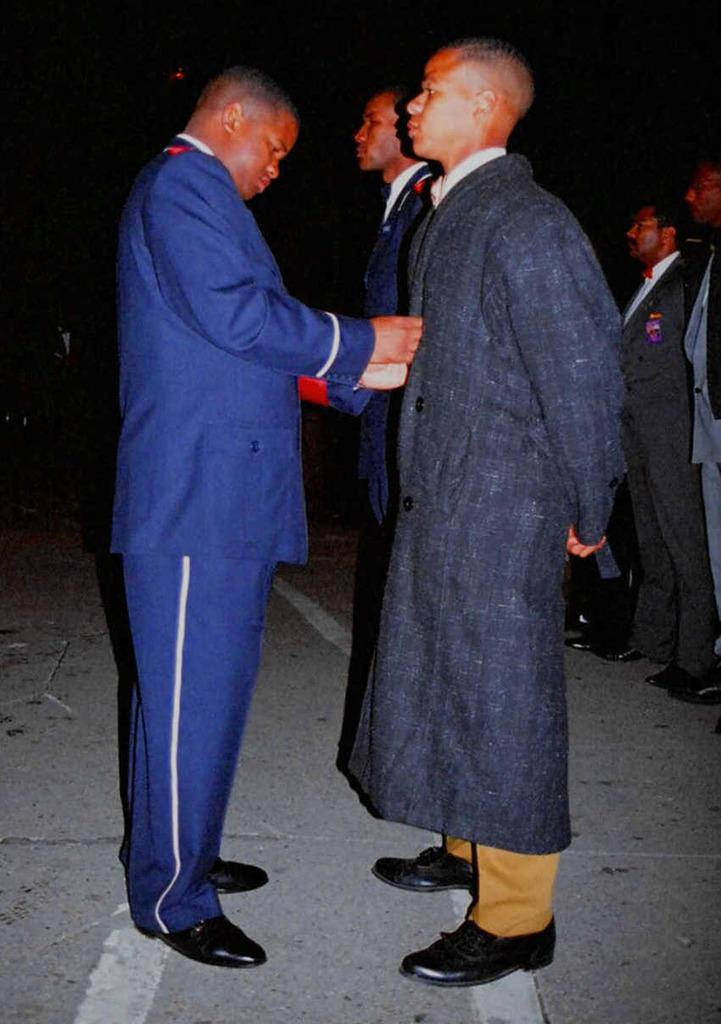What are the people in the image doing? The men in the image are standing. What are the men wearing? The men are wearing suits. What can be observed about the background of the image? The background of the image is dark. What is the fifth man in the image doing? There is no mention of a fifth man in the image, so we cannot answer this question. 